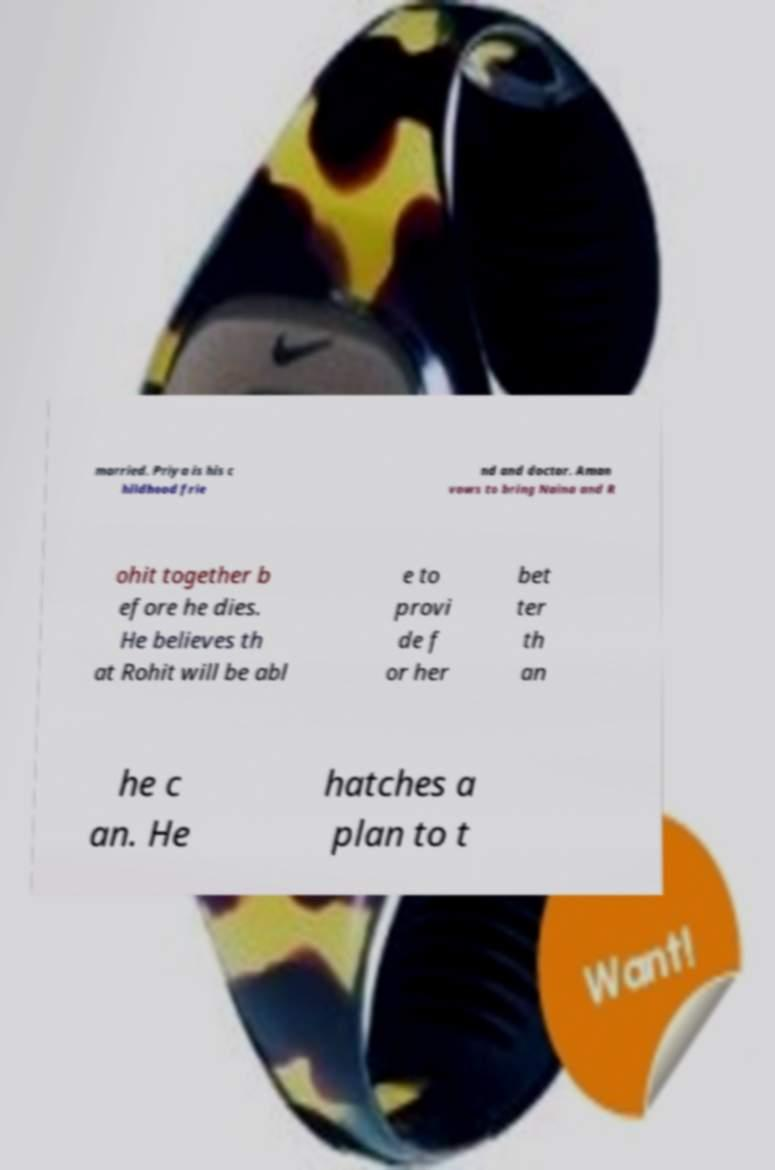Can you accurately transcribe the text from the provided image for me? married. Priya is his c hildhood frie nd and doctor. Aman vows to bring Naina and R ohit together b efore he dies. He believes th at Rohit will be abl e to provi de f or her bet ter th an he c an. He hatches a plan to t 